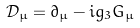Convert formula to latex. <formula><loc_0><loc_0><loc_500><loc_500>\mathcal { D } _ { \mu } = \partial _ { \mu } - i g _ { 3 } G _ { \mu }</formula> 